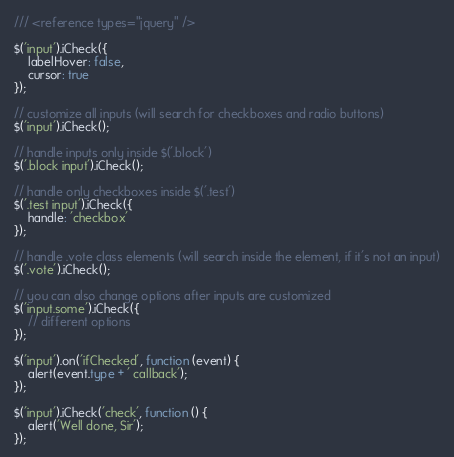<code> <loc_0><loc_0><loc_500><loc_500><_TypeScript_>/// <reference types="jquery" />

$('input').iCheck({
    labelHover: false,
    cursor: true
});

// customize all inputs (will search for checkboxes and radio buttons)
$('input').iCheck();

// handle inputs only inside $('.block')
$('.block input').iCheck();

// handle only checkboxes inside $('.test')
$('.test input').iCheck({
    handle: 'checkbox'
});

// handle .vote class elements (will search inside the element, if it's not an input)
$('.vote').iCheck();

// you can also change options after inputs are customized
$('input.some').iCheck({
    // different options
});

$('input').on('ifChecked', function (event) {
    alert(event.type + ' callback');
});

$('input').iCheck('check', function () {
    alert('Well done, Sir');
});</code> 